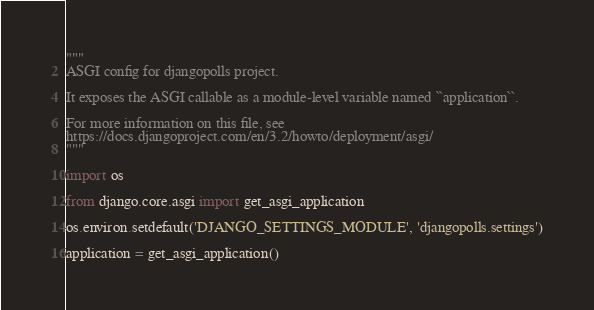<code> <loc_0><loc_0><loc_500><loc_500><_Python_>"""
ASGI config for djangopolls project.

It exposes the ASGI callable as a module-level variable named ``application``.

For more information on this file, see
https://docs.djangoproject.com/en/3.2/howto/deployment/asgi/
"""

import os

from django.core.asgi import get_asgi_application

os.environ.setdefault('DJANGO_SETTINGS_MODULE', 'djangopolls.settings')

application = get_asgi_application()
</code> 